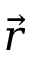<formula> <loc_0><loc_0><loc_500><loc_500>\vec { r }</formula> 